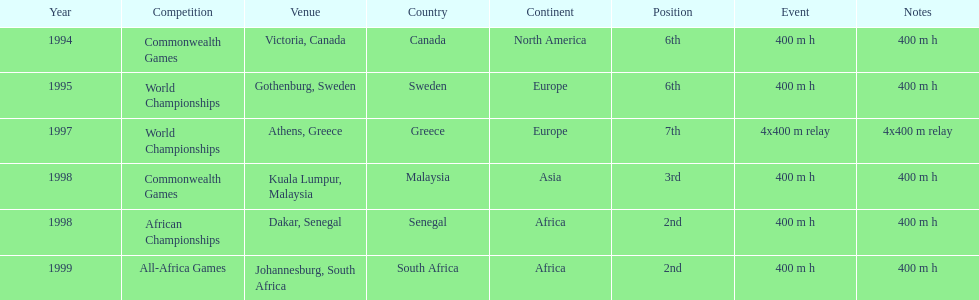What is the last competition on the chart? All-Africa Games. 